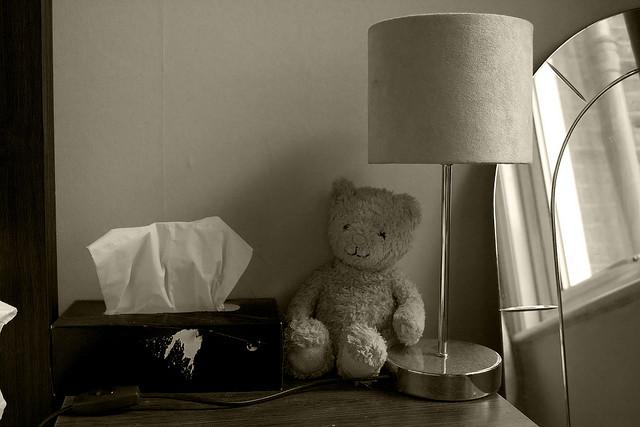Whose feet are these?
Keep it brief. Bears. What is reflected in the mirror?
Give a very brief answer. Window. Is the light on?
Short answer required. No. What kind of room is this?
Short answer required. Bedroom. What is next to the bear on the left?
Answer briefly. Tissues. Are the legs crossed?
Short answer required. No. 